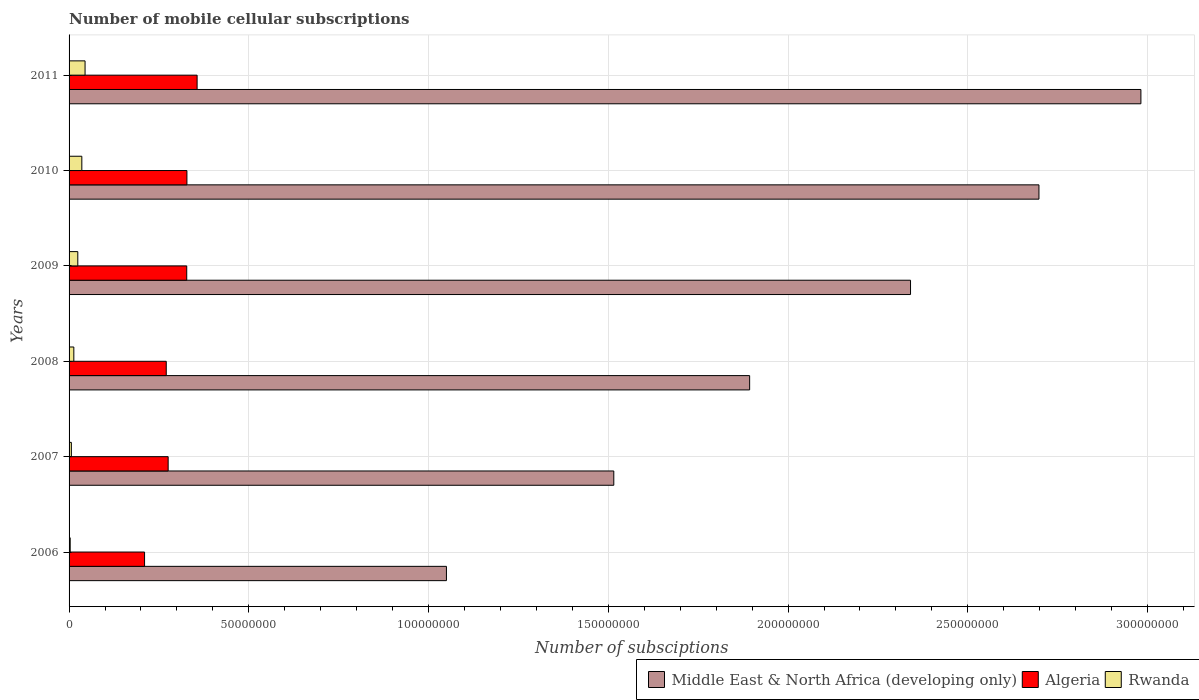What is the number of mobile cellular subscriptions in Middle East & North Africa (developing only) in 2007?
Give a very brief answer. 1.52e+08. Across all years, what is the maximum number of mobile cellular subscriptions in Rwanda?
Keep it short and to the point. 4.45e+06. Across all years, what is the minimum number of mobile cellular subscriptions in Algeria?
Offer a terse response. 2.10e+07. What is the total number of mobile cellular subscriptions in Rwanda in the graph?
Keep it short and to the point. 1.27e+07. What is the difference between the number of mobile cellular subscriptions in Middle East & North Africa (developing only) in 2006 and that in 2011?
Ensure brevity in your answer.  -1.93e+08. What is the difference between the number of mobile cellular subscriptions in Algeria in 2009 and the number of mobile cellular subscriptions in Rwanda in 2007?
Provide a succinct answer. 3.21e+07. What is the average number of mobile cellular subscriptions in Algeria per year?
Provide a short and direct response. 2.95e+07. In the year 2006, what is the difference between the number of mobile cellular subscriptions in Algeria and number of mobile cellular subscriptions in Rwanda?
Provide a short and direct response. 2.07e+07. What is the ratio of the number of mobile cellular subscriptions in Middle East & North Africa (developing only) in 2006 to that in 2007?
Offer a terse response. 0.69. Is the number of mobile cellular subscriptions in Middle East & North Africa (developing only) in 2009 less than that in 2010?
Offer a terse response. Yes. What is the difference between the highest and the second highest number of mobile cellular subscriptions in Middle East & North Africa (developing only)?
Provide a succinct answer. 2.84e+07. What is the difference between the highest and the lowest number of mobile cellular subscriptions in Middle East & North Africa (developing only)?
Offer a terse response. 1.93e+08. What does the 3rd bar from the top in 2007 represents?
Provide a short and direct response. Middle East & North Africa (developing only). What does the 2nd bar from the bottom in 2009 represents?
Offer a very short reply. Algeria. Is it the case that in every year, the sum of the number of mobile cellular subscriptions in Middle East & North Africa (developing only) and number of mobile cellular subscriptions in Rwanda is greater than the number of mobile cellular subscriptions in Algeria?
Provide a short and direct response. Yes. How many bars are there?
Offer a very short reply. 18. Are all the bars in the graph horizontal?
Your response must be concise. Yes. How many years are there in the graph?
Provide a succinct answer. 6. What is the difference between two consecutive major ticks on the X-axis?
Provide a short and direct response. 5.00e+07. Where does the legend appear in the graph?
Give a very brief answer. Bottom right. How many legend labels are there?
Your response must be concise. 3. How are the legend labels stacked?
Your answer should be very brief. Horizontal. What is the title of the graph?
Ensure brevity in your answer.  Number of mobile cellular subscriptions. Does "Liechtenstein" appear as one of the legend labels in the graph?
Offer a very short reply. No. What is the label or title of the X-axis?
Offer a very short reply. Number of subsciptions. What is the Number of subsciptions of Middle East & North Africa (developing only) in 2006?
Provide a succinct answer. 1.05e+08. What is the Number of subsciptions of Algeria in 2006?
Your response must be concise. 2.10e+07. What is the Number of subsciptions in Rwanda in 2006?
Ensure brevity in your answer.  3.14e+05. What is the Number of subsciptions of Middle East & North Africa (developing only) in 2007?
Keep it short and to the point. 1.52e+08. What is the Number of subsciptions of Algeria in 2007?
Your response must be concise. 2.76e+07. What is the Number of subsciptions in Rwanda in 2007?
Your response must be concise. 6.35e+05. What is the Number of subsciptions in Middle East & North Africa (developing only) in 2008?
Make the answer very short. 1.89e+08. What is the Number of subsciptions of Algeria in 2008?
Provide a short and direct response. 2.70e+07. What is the Number of subsciptions of Rwanda in 2008?
Provide a short and direct response. 1.32e+06. What is the Number of subsciptions of Middle East & North Africa (developing only) in 2009?
Give a very brief answer. 2.34e+08. What is the Number of subsciptions of Algeria in 2009?
Offer a very short reply. 3.27e+07. What is the Number of subsciptions in Rwanda in 2009?
Offer a terse response. 2.43e+06. What is the Number of subsciptions of Middle East & North Africa (developing only) in 2010?
Give a very brief answer. 2.70e+08. What is the Number of subsciptions in Algeria in 2010?
Offer a terse response. 3.28e+07. What is the Number of subsciptions of Rwanda in 2010?
Your response must be concise. 3.55e+06. What is the Number of subsciptions of Middle East & North Africa (developing only) in 2011?
Ensure brevity in your answer.  2.98e+08. What is the Number of subsciptions in Algeria in 2011?
Make the answer very short. 3.56e+07. What is the Number of subsciptions of Rwanda in 2011?
Ensure brevity in your answer.  4.45e+06. Across all years, what is the maximum Number of subsciptions in Middle East & North Africa (developing only)?
Make the answer very short. 2.98e+08. Across all years, what is the maximum Number of subsciptions in Algeria?
Your answer should be very brief. 3.56e+07. Across all years, what is the maximum Number of subsciptions of Rwanda?
Give a very brief answer. 4.45e+06. Across all years, what is the minimum Number of subsciptions in Middle East & North Africa (developing only)?
Keep it short and to the point. 1.05e+08. Across all years, what is the minimum Number of subsciptions in Algeria?
Offer a very short reply. 2.10e+07. Across all years, what is the minimum Number of subsciptions of Rwanda?
Make the answer very short. 3.14e+05. What is the total Number of subsciptions of Middle East & North Africa (developing only) in the graph?
Offer a very short reply. 1.25e+09. What is the total Number of subsciptions in Algeria in the graph?
Provide a short and direct response. 1.77e+08. What is the total Number of subsciptions of Rwanda in the graph?
Your answer should be compact. 1.27e+07. What is the difference between the Number of subsciptions in Middle East & North Africa (developing only) in 2006 and that in 2007?
Make the answer very short. -4.66e+07. What is the difference between the Number of subsciptions in Algeria in 2006 and that in 2007?
Make the answer very short. -6.56e+06. What is the difference between the Number of subsciptions of Rwanda in 2006 and that in 2007?
Provide a succinct answer. -3.21e+05. What is the difference between the Number of subsciptions of Middle East & North Africa (developing only) in 2006 and that in 2008?
Ensure brevity in your answer.  -8.43e+07. What is the difference between the Number of subsciptions in Algeria in 2006 and that in 2008?
Ensure brevity in your answer.  -6.03e+06. What is the difference between the Number of subsciptions of Rwanda in 2006 and that in 2008?
Keep it short and to the point. -1.01e+06. What is the difference between the Number of subsciptions in Middle East & North Africa (developing only) in 2006 and that in 2009?
Offer a terse response. -1.29e+08. What is the difference between the Number of subsciptions in Algeria in 2006 and that in 2009?
Make the answer very short. -1.17e+07. What is the difference between the Number of subsciptions of Rwanda in 2006 and that in 2009?
Offer a very short reply. -2.12e+06. What is the difference between the Number of subsciptions in Middle East & North Africa (developing only) in 2006 and that in 2010?
Keep it short and to the point. -1.65e+08. What is the difference between the Number of subsciptions in Algeria in 2006 and that in 2010?
Ensure brevity in your answer.  -1.18e+07. What is the difference between the Number of subsciptions of Rwanda in 2006 and that in 2010?
Keep it short and to the point. -3.23e+06. What is the difference between the Number of subsciptions of Middle East & North Africa (developing only) in 2006 and that in 2011?
Keep it short and to the point. -1.93e+08. What is the difference between the Number of subsciptions of Algeria in 2006 and that in 2011?
Offer a terse response. -1.46e+07. What is the difference between the Number of subsciptions in Rwanda in 2006 and that in 2011?
Ensure brevity in your answer.  -4.13e+06. What is the difference between the Number of subsciptions of Middle East & North Africa (developing only) in 2007 and that in 2008?
Keep it short and to the point. -3.78e+07. What is the difference between the Number of subsciptions of Algeria in 2007 and that in 2008?
Offer a terse response. 5.31e+05. What is the difference between the Number of subsciptions of Rwanda in 2007 and that in 2008?
Offer a very short reply. -6.88e+05. What is the difference between the Number of subsciptions of Middle East & North Africa (developing only) in 2007 and that in 2009?
Ensure brevity in your answer.  -8.25e+07. What is the difference between the Number of subsciptions of Algeria in 2007 and that in 2009?
Your answer should be compact. -5.17e+06. What is the difference between the Number of subsciptions in Rwanda in 2007 and that in 2009?
Give a very brief answer. -1.79e+06. What is the difference between the Number of subsciptions of Middle East & North Africa (developing only) in 2007 and that in 2010?
Offer a very short reply. -1.18e+08. What is the difference between the Number of subsciptions of Algeria in 2007 and that in 2010?
Provide a succinct answer. -5.22e+06. What is the difference between the Number of subsciptions of Rwanda in 2007 and that in 2010?
Ensure brevity in your answer.  -2.91e+06. What is the difference between the Number of subsciptions in Middle East & North Africa (developing only) in 2007 and that in 2011?
Your response must be concise. -1.47e+08. What is the difference between the Number of subsciptions in Algeria in 2007 and that in 2011?
Ensure brevity in your answer.  -8.05e+06. What is the difference between the Number of subsciptions of Rwanda in 2007 and that in 2011?
Your answer should be very brief. -3.81e+06. What is the difference between the Number of subsciptions of Middle East & North Africa (developing only) in 2008 and that in 2009?
Your answer should be compact. -4.48e+07. What is the difference between the Number of subsciptions in Algeria in 2008 and that in 2009?
Offer a terse response. -5.70e+06. What is the difference between the Number of subsciptions in Rwanda in 2008 and that in 2009?
Your answer should be compact. -1.11e+06. What is the difference between the Number of subsciptions in Middle East & North Africa (developing only) in 2008 and that in 2010?
Give a very brief answer. -8.05e+07. What is the difference between the Number of subsciptions of Algeria in 2008 and that in 2010?
Ensure brevity in your answer.  -5.75e+06. What is the difference between the Number of subsciptions of Rwanda in 2008 and that in 2010?
Give a very brief answer. -2.23e+06. What is the difference between the Number of subsciptions of Middle East & North Africa (developing only) in 2008 and that in 2011?
Give a very brief answer. -1.09e+08. What is the difference between the Number of subsciptions of Algeria in 2008 and that in 2011?
Provide a short and direct response. -8.58e+06. What is the difference between the Number of subsciptions of Rwanda in 2008 and that in 2011?
Offer a very short reply. -3.12e+06. What is the difference between the Number of subsciptions of Middle East & North Africa (developing only) in 2009 and that in 2010?
Provide a succinct answer. -3.57e+07. What is the difference between the Number of subsciptions of Algeria in 2009 and that in 2010?
Your answer should be compact. -5.03e+04. What is the difference between the Number of subsciptions of Rwanda in 2009 and that in 2010?
Give a very brief answer. -1.12e+06. What is the difference between the Number of subsciptions of Middle East & North Africa (developing only) in 2009 and that in 2011?
Your response must be concise. -6.41e+07. What is the difference between the Number of subsciptions of Algeria in 2009 and that in 2011?
Offer a very short reply. -2.89e+06. What is the difference between the Number of subsciptions of Rwanda in 2009 and that in 2011?
Ensure brevity in your answer.  -2.02e+06. What is the difference between the Number of subsciptions of Middle East & North Africa (developing only) in 2010 and that in 2011?
Your answer should be very brief. -2.84e+07. What is the difference between the Number of subsciptions in Algeria in 2010 and that in 2011?
Provide a succinct answer. -2.84e+06. What is the difference between the Number of subsciptions in Rwanda in 2010 and that in 2011?
Ensure brevity in your answer.  -8.97e+05. What is the difference between the Number of subsciptions in Middle East & North Africa (developing only) in 2006 and the Number of subsciptions in Algeria in 2007?
Ensure brevity in your answer.  7.74e+07. What is the difference between the Number of subsciptions of Middle East & North Africa (developing only) in 2006 and the Number of subsciptions of Rwanda in 2007?
Provide a short and direct response. 1.04e+08. What is the difference between the Number of subsciptions in Algeria in 2006 and the Number of subsciptions in Rwanda in 2007?
Your response must be concise. 2.04e+07. What is the difference between the Number of subsciptions in Middle East & North Africa (developing only) in 2006 and the Number of subsciptions in Algeria in 2008?
Offer a terse response. 7.79e+07. What is the difference between the Number of subsciptions in Middle East & North Africa (developing only) in 2006 and the Number of subsciptions in Rwanda in 2008?
Make the answer very short. 1.04e+08. What is the difference between the Number of subsciptions of Algeria in 2006 and the Number of subsciptions of Rwanda in 2008?
Provide a succinct answer. 1.97e+07. What is the difference between the Number of subsciptions of Middle East & North Africa (developing only) in 2006 and the Number of subsciptions of Algeria in 2009?
Offer a terse response. 7.22e+07. What is the difference between the Number of subsciptions in Middle East & North Africa (developing only) in 2006 and the Number of subsciptions in Rwanda in 2009?
Keep it short and to the point. 1.03e+08. What is the difference between the Number of subsciptions in Algeria in 2006 and the Number of subsciptions in Rwanda in 2009?
Ensure brevity in your answer.  1.86e+07. What is the difference between the Number of subsciptions in Middle East & North Africa (developing only) in 2006 and the Number of subsciptions in Algeria in 2010?
Provide a succinct answer. 7.22e+07. What is the difference between the Number of subsciptions of Middle East & North Africa (developing only) in 2006 and the Number of subsciptions of Rwanda in 2010?
Provide a succinct answer. 1.01e+08. What is the difference between the Number of subsciptions of Algeria in 2006 and the Number of subsciptions of Rwanda in 2010?
Your answer should be compact. 1.74e+07. What is the difference between the Number of subsciptions of Middle East & North Africa (developing only) in 2006 and the Number of subsciptions of Algeria in 2011?
Make the answer very short. 6.94e+07. What is the difference between the Number of subsciptions in Middle East & North Africa (developing only) in 2006 and the Number of subsciptions in Rwanda in 2011?
Offer a terse response. 1.01e+08. What is the difference between the Number of subsciptions of Algeria in 2006 and the Number of subsciptions of Rwanda in 2011?
Keep it short and to the point. 1.66e+07. What is the difference between the Number of subsciptions of Middle East & North Africa (developing only) in 2007 and the Number of subsciptions of Algeria in 2008?
Your response must be concise. 1.24e+08. What is the difference between the Number of subsciptions in Middle East & North Africa (developing only) in 2007 and the Number of subsciptions in Rwanda in 2008?
Keep it short and to the point. 1.50e+08. What is the difference between the Number of subsciptions of Algeria in 2007 and the Number of subsciptions of Rwanda in 2008?
Ensure brevity in your answer.  2.62e+07. What is the difference between the Number of subsciptions in Middle East & North Africa (developing only) in 2007 and the Number of subsciptions in Algeria in 2009?
Your answer should be compact. 1.19e+08. What is the difference between the Number of subsciptions of Middle East & North Africa (developing only) in 2007 and the Number of subsciptions of Rwanda in 2009?
Provide a short and direct response. 1.49e+08. What is the difference between the Number of subsciptions in Algeria in 2007 and the Number of subsciptions in Rwanda in 2009?
Make the answer very short. 2.51e+07. What is the difference between the Number of subsciptions of Middle East & North Africa (developing only) in 2007 and the Number of subsciptions of Algeria in 2010?
Ensure brevity in your answer.  1.19e+08. What is the difference between the Number of subsciptions of Middle East & North Africa (developing only) in 2007 and the Number of subsciptions of Rwanda in 2010?
Offer a terse response. 1.48e+08. What is the difference between the Number of subsciptions of Algeria in 2007 and the Number of subsciptions of Rwanda in 2010?
Ensure brevity in your answer.  2.40e+07. What is the difference between the Number of subsciptions of Middle East & North Africa (developing only) in 2007 and the Number of subsciptions of Algeria in 2011?
Give a very brief answer. 1.16e+08. What is the difference between the Number of subsciptions of Middle East & North Africa (developing only) in 2007 and the Number of subsciptions of Rwanda in 2011?
Offer a very short reply. 1.47e+08. What is the difference between the Number of subsciptions in Algeria in 2007 and the Number of subsciptions in Rwanda in 2011?
Your answer should be very brief. 2.31e+07. What is the difference between the Number of subsciptions in Middle East & North Africa (developing only) in 2008 and the Number of subsciptions in Algeria in 2009?
Keep it short and to the point. 1.57e+08. What is the difference between the Number of subsciptions in Middle East & North Africa (developing only) in 2008 and the Number of subsciptions in Rwanda in 2009?
Ensure brevity in your answer.  1.87e+08. What is the difference between the Number of subsciptions of Algeria in 2008 and the Number of subsciptions of Rwanda in 2009?
Your response must be concise. 2.46e+07. What is the difference between the Number of subsciptions in Middle East & North Africa (developing only) in 2008 and the Number of subsciptions in Algeria in 2010?
Provide a succinct answer. 1.57e+08. What is the difference between the Number of subsciptions of Middle East & North Africa (developing only) in 2008 and the Number of subsciptions of Rwanda in 2010?
Provide a succinct answer. 1.86e+08. What is the difference between the Number of subsciptions of Algeria in 2008 and the Number of subsciptions of Rwanda in 2010?
Your answer should be compact. 2.35e+07. What is the difference between the Number of subsciptions of Middle East & North Africa (developing only) in 2008 and the Number of subsciptions of Algeria in 2011?
Ensure brevity in your answer.  1.54e+08. What is the difference between the Number of subsciptions in Middle East & North Africa (developing only) in 2008 and the Number of subsciptions in Rwanda in 2011?
Offer a terse response. 1.85e+08. What is the difference between the Number of subsciptions of Algeria in 2008 and the Number of subsciptions of Rwanda in 2011?
Ensure brevity in your answer.  2.26e+07. What is the difference between the Number of subsciptions in Middle East & North Africa (developing only) in 2009 and the Number of subsciptions in Algeria in 2010?
Provide a succinct answer. 2.01e+08. What is the difference between the Number of subsciptions of Middle East & North Africa (developing only) in 2009 and the Number of subsciptions of Rwanda in 2010?
Your answer should be compact. 2.31e+08. What is the difference between the Number of subsciptions of Algeria in 2009 and the Number of subsciptions of Rwanda in 2010?
Offer a terse response. 2.92e+07. What is the difference between the Number of subsciptions in Middle East & North Africa (developing only) in 2009 and the Number of subsciptions in Algeria in 2011?
Make the answer very short. 1.98e+08. What is the difference between the Number of subsciptions in Middle East & North Africa (developing only) in 2009 and the Number of subsciptions in Rwanda in 2011?
Provide a short and direct response. 2.30e+08. What is the difference between the Number of subsciptions of Algeria in 2009 and the Number of subsciptions of Rwanda in 2011?
Your answer should be very brief. 2.83e+07. What is the difference between the Number of subsciptions of Middle East & North Africa (developing only) in 2010 and the Number of subsciptions of Algeria in 2011?
Provide a short and direct response. 2.34e+08. What is the difference between the Number of subsciptions in Middle East & North Africa (developing only) in 2010 and the Number of subsciptions in Rwanda in 2011?
Your answer should be very brief. 2.65e+08. What is the difference between the Number of subsciptions in Algeria in 2010 and the Number of subsciptions in Rwanda in 2011?
Keep it short and to the point. 2.83e+07. What is the average Number of subsciptions in Middle East & North Africa (developing only) per year?
Your answer should be very brief. 2.08e+08. What is the average Number of subsciptions of Algeria per year?
Keep it short and to the point. 2.95e+07. What is the average Number of subsciptions of Rwanda per year?
Your answer should be compact. 2.12e+06. In the year 2006, what is the difference between the Number of subsciptions in Middle East & North Africa (developing only) and Number of subsciptions in Algeria?
Provide a succinct answer. 8.40e+07. In the year 2006, what is the difference between the Number of subsciptions in Middle East & North Africa (developing only) and Number of subsciptions in Rwanda?
Offer a very short reply. 1.05e+08. In the year 2006, what is the difference between the Number of subsciptions in Algeria and Number of subsciptions in Rwanda?
Offer a very short reply. 2.07e+07. In the year 2007, what is the difference between the Number of subsciptions of Middle East & North Africa (developing only) and Number of subsciptions of Algeria?
Ensure brevity in your answer.  1.24e+08. In the year 2007, what is the difference between the Number of subsciptions in Middle East & North Africa (developing only) and Number of subsciptions in Rwanda?
Your answer should be very brief. 1.51e+08. In the year 2007, what is the difference between the Number of subsciptions in Algeria and Number of subsciptions in Rwanda?
Offer a very short reply. 2.69e+07. In the year 2008, what is the difference between the Number of subsciptions of Middle East & North Africa (developing only) and Number of subsciptions of Algeria?
Your answer should be compact. 1.62e+08. In the year 2008, what is the difference between the Number of subsciptions in Middle East & North Africa (developing only) and Number of subsciptions in Rwanda?
Make the answer very short. 1.88e+08. In the year 2008, what is the difference between the Number of subsciptions in Algeria and Number of subsciptions in Rwanda?
Give a very brief answer. 2.57e+07. In the year 2009, what is the difference between the Number of subsciptions in Middle East & North Africa (developing only) and Number of subsciptions in Algeria?
Ensure brevity in your answer.  2.01e+08. In the year 2009, what is the difference between the Number of subsciptions in Middle East & North Africa (developing only) and Number of subsciptions in Rwanda?
Give a very brief answer. 2.32e+08. In the year 2009, what is the difference between the Number of subsciptions in Algeria and Number of subsciptions in Rwanda?
Make the answer very short. 3.03e+07. In the year 2010, what is the difference between the Number of subsciptions of Middle East & North Africa (developing only) and Number of subsciptions of Algeria?
Your answer should be compact. 2.37e+08. In the year 2010, what is the difference between the Number of subsciptions of Middle East & North Africa (developing only) and Number of subsciptions of Rwanda?
Your response must be concise. 2.66e+08. In the year 2010, what is the difference between the Number of subsciptions of Algeria and Number of subsciptions of Rwanda?
Your response must be concise. 2.92e+07. In the year 2011, what is the difference between the Number of subsciptions of Middle East & North Africa (developing only) and Number of subsciptions of Algeria?
Provide a succinct answer. 2.63e+08. In the year 2011, what is the difference between the Number of subsciptions in Middle East & North Africa (developing only) and Number of subsciptions in Rwanda?
Provide a short and direct response. 2.94e+08. In the year 2011, what is the difference between the Number of subsciptions of Algeria and Number of subsciptions of Rwanda?
Give a very brief answer. 3.12e+07. What is the ratio of the Number of subsciptions of Middle East & North Africa (developing only) in 2006 to that in 2007?
Keep it short and to the point. 0.69. What is the ratio of the Number of subsciptions of Algeria in 2006 to that in 2007?
Your answer should be very brief. 0.76. What is the ratio of the Number of subsciptions of Rwanda in 2006 to that in 2007?
Keep it short and to the point. 0.49. What is the ratio of the Number of subsciptions of Middle East & North Africa (developing only) in 2006 to that in 2008?
Offer a very short reply. 0.55. What is the ratio of the Number of subsciptions in Algeria in 2006 to that in 2008?
Keep it short and to the point. 0.78. What is the ratio of the Number of subsciptions in Rwanda in 2006 to that in 2008?
Your answer should be very brief. 0.24. What is the ratio of the Number of subsciptions of Middle East & North Africa (developing only) in 2006 to that in 2009?
Make the answer very short. 0.45. What is the ratio of the Number of subsciptions in Algeria in 2006 to that in 2009?
Offer a terse response. 0.64. What is the ratio of the Number of subsciptions of Rwanda in 2006 to that in 2009?
Your response must be concise. 0.13. What is the ratio of the Number of subsciptions of Middle East & North Africa (developing only) in 2006 to that in 2010?
Offer a very short reply. 0.39. What is the ratio of the Number of subsciptions of Algeria in 2006 to that in 2010?
Provide a succinct answer. 0.64. What is the ratio of the Number of subsciptions in Rwanda in 2006 to that in 2010?
Make the answer very short. 0.09. What is the ratio of the Number of subsciptions of Middle East & North Africa (developing only) in 2006 to that in 2011?
Your answer should be compact. 0.35. What is the ratio of the Number of subsciptions in Algeria in 2006 to that in 2011?
Keep it short and to the point. 0.59. What is the ratio of the Number of subsciptions of Rwanda in 2006 to that in 2011?
Your answer should be compact. 0.07. What is the ratio of the Number of subsciptions in Middle East & North Africa (developing only) in 2007 to that in 2008?
Give a very brief answer. 0.8. What is the ratio of the Number of subsciptions in Algeria in 2007 to that in 2008?
Keep it short and to the point. 1.02. What is the ratio of the Number of subsciptions of Rwanda in 2007 to that in 2008?
Your answer should be compact. 0.48. What is the ratio of the Number of subsciptions in Middle East & North Africa (developing only) in 2007 to that in 2009?
Ensure brevity in your answer.  0.65. What is the ratio of the Number of subsciptions of Algeria in 2007 to that in 2009?
Provide a short and direct response. 0.84. What is the ratio of the Number of subsciptions of Rwanda in 2007 to that in 2009?
Make the answer very short. 0.26. What is the ratio of the Number of subsciptions of Middle East & North Africa (developing only) in 2007 to that in 2010?
Keep it short and to the point. 0.56. What is the ratio of the Number of subsciptions of Algeria in 2007 to that in 2010?
Provide a succinct answer. 0.84. What is the ratio of the Number of subsciptions of Rwanda in 2007 to that in 2010?
Provide a succinct answer. 0.18. What is the ratio of the Number of subsciptions of Middle East & North Africa (developing only) in 2007 to that in 2011?
Make the answer very short. 0.51. What is the ratio of the Number of subsciptions of Algeria in 2007 to that in 2011?
Make the answer very short. 0.77. What is the ratio of the Number of subsciptions of Rwanda in 2007 to that in 2011?
Provide a succinct answer. 0.14. What is the ratio of the Number of subsciptions in Middle East & North Africa (developing only) in 2008 to that in 2009?
Provide a short and direct response. 0.81. What is the ratio of the Number of subsciptions in Algeria in 2008 to that in 2009?
Ensure brevity in your answer.  0.83. What is the ratio of the Number of subsciptions of Rwanda in 2008 to that in 2009?
Offer a terse response. 0.54. What is the ratio of the Number of subsciptions in Middle East & North Africa (developing only) in 2008 to that in 2010?
Provide a succinct answer. 0.7. What is the ratio of the Number of subsciptions of Algeria in 2008 to that in 2010?
Make the answer very short. 0.82. What is the ratio of the Number of subsciptions in Rwanda in 2008 to that in 2010?
Provide a succinct answer. 0.37. What is the ratio of the Number of subsciptions in Middle East & North Africa (developing only) in 2008 to that in 2011?
Your response must be concise. 0.64. What is the ratio of the Number of subsciptions of Algeria in 2008 to that in 2011?
Give a very brief answer. 0.76. What is the ratio of the Number of subsciptions of Rwanda in 2008 to that in 2011?
Ensure brevity in your answer.  0.3. What is the ratio of the Number of subsciptions in Middle East & North Africa (developing only) in 2009 to that in 2010?
Offer a terse response. 0.87. What is the ratio of the Number of subsciptions of Rwanda in 2009 to that in 2010?
Provide a succinct answer. 0.68. What is the ratio of the Number of subsciptions of Middle East & North Africa (developing only) in 2009 to that in 2011?
Keep it short and to the point. 0.79. What is the ratio of the Number of subsciptions of Algeria in 2009 to that in 2011?
Your answer should be compact. 0.92. What is the ratio of the Number of subsciptions in Rwanda in 2009 to that in 2011?
Provide a short and direct response. 0.55. What is the ratio of the Number of subsciptions in Middle East & North Africa (developing only) in 2010 to that in 2011?
Offer a very short reply. 0.9. What is the ratio of the Number of subsciptions in Algeria in 2010 to that in 2011?
Your answer should be compact. 0.92. What is the ratio of the Number of subsciptions in Rwanda in 2010 to that in 2011?
Give a very brief answer. 0.8. What is the difference between the highest and the second highest Number of subsciptions of Middle East & North Africa (developing only)?
Your answer should be very brief. 2.84e+07. What is the difference between the highest and the second highest Number of subsciptions in Algeria?
Provide a short and direct response. 2.84e+06. What is the difference between the highest and the second highest Number of subsciptions in Rwanda?
Your answer should be very brief. 8.97e+05. What is the difference between the highest and the lowest Number of subsciptions of Middle East & North Africa (developing only)?
Your answer should be compact. 1.93e+08. What is the difference between the highest and the lowest Number of subsciptions of Algeria?
Your answer should be compact. 1.46e+07. What is the difference between the highest and the lowest Number of subsciptions of Rwanda?
Provide a short and direct response. 4.13e+06. 